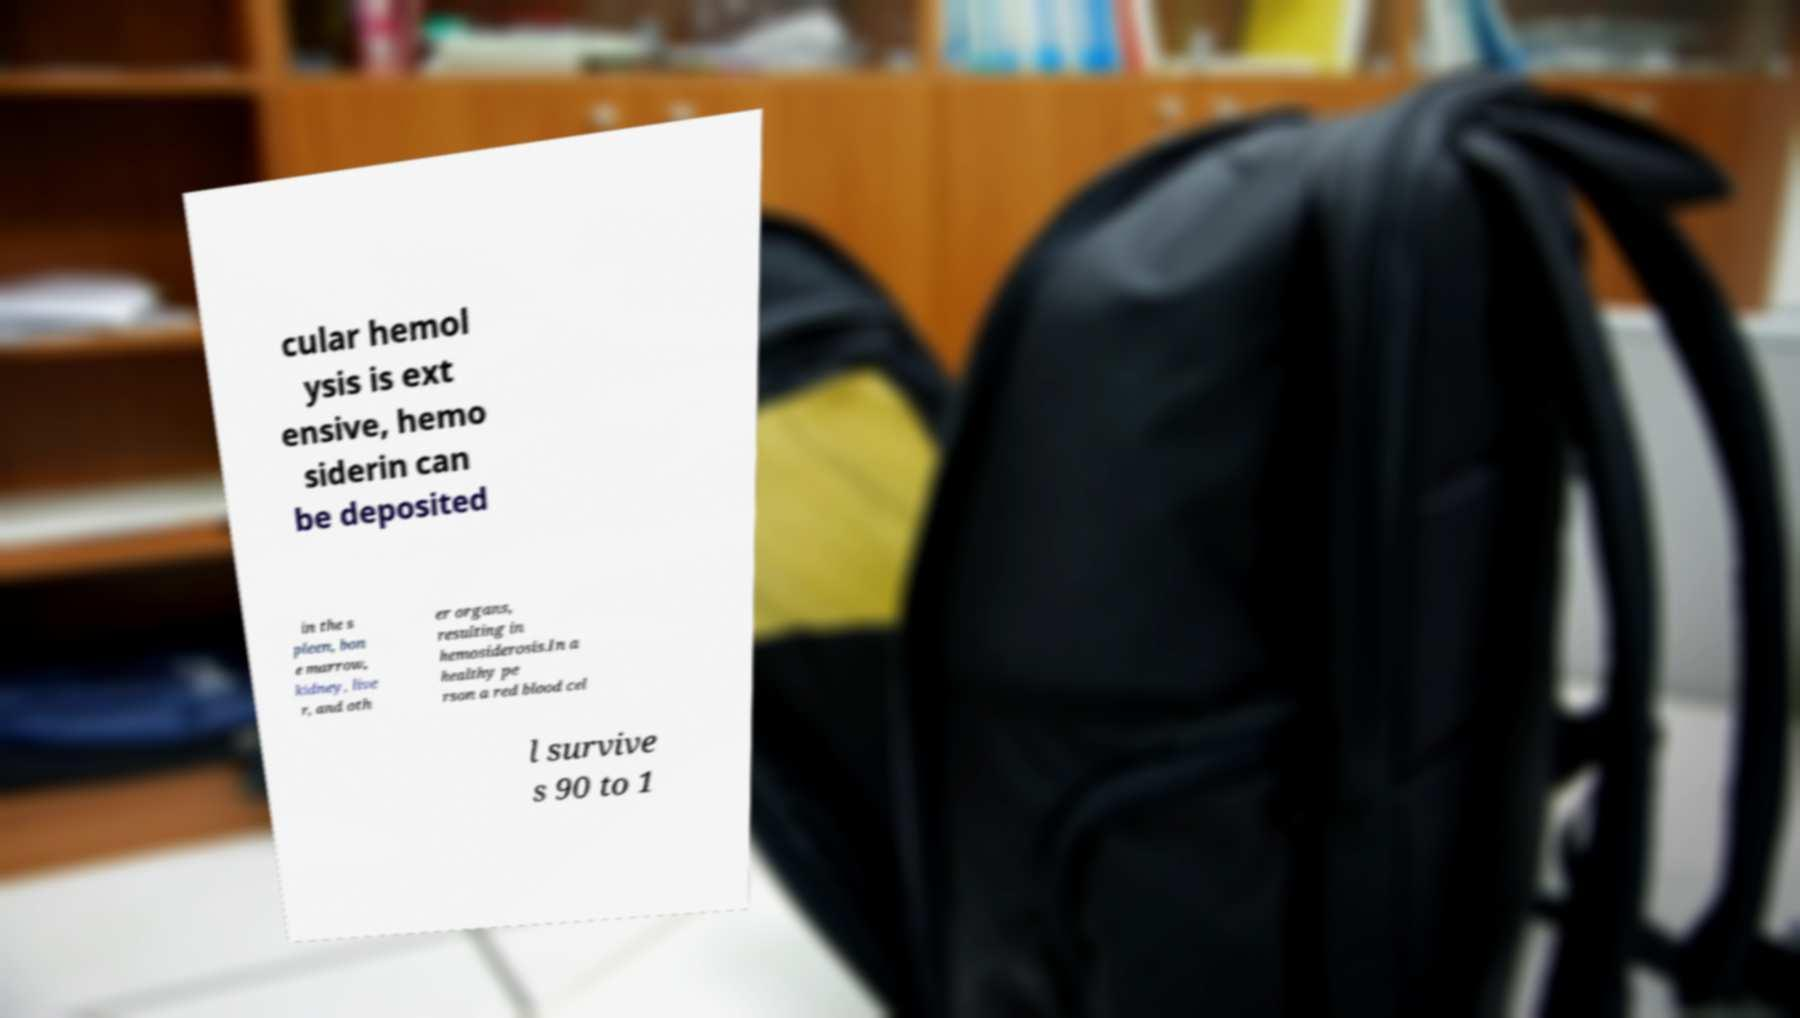For documentation purposes, I need the text within this image transcribed. Could you provide that? cular hemol ysis is ext ensive, hemo siderin can be deposited in the s pleen, bon e marrow, kidney, live r, and oth er organs, resulting in hemosiderosis.In a healthy pe rson a red blood cel l survive s 90 to 1 